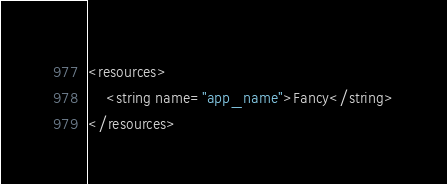Convert code to text. <code><loc_0><loc_0><loc_500><loc_500><_XML_><resources>
    <string name="app_name">Fancy</string>
</resources>
</code> 